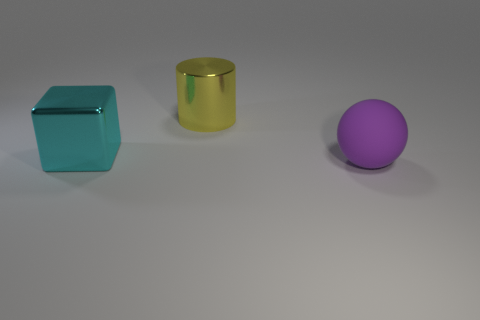Add 2 purple spheres. How many objects exist? 5 Subtract all blocks. How many objects are left? 2 Add 1 red blocks. How many red blocks exist? 1 Subtract 1 cyan cubes. How many objects are left? 2 Subtract all big green blocks. Subtract all shiny objects. How many objects are left? 1 Add 1 large cyan metal cubes. How many large cyan metal cubes are left? 2 